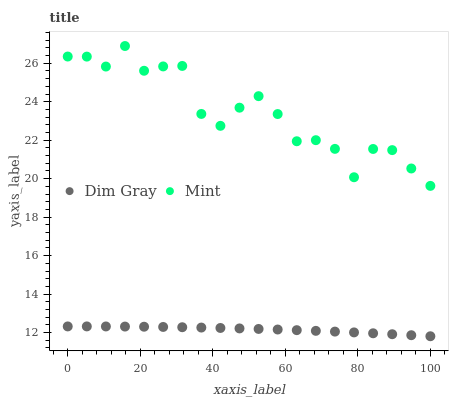Does Dim Gray have the minimum area under the curve?
Answer yes or no. Yes. Does Mint have the maximum area under the curve?
Answer yes or no. Yes. Does Mint have the minimum area under the curve?
Answer yes or no. No. Is Dim Gray the smoothest?
Answer yes or no. Yes. Is Mint the roughest?
Answer yes or no. Yes. Is Mint the smoothest?
Answer yes or no. No. Does Dim Gray have the lowest value?
Answer yes or no. Yes. Does Mint have the lowest value?
Answer yes or no. No. Does Mint have the highest value?
Answer yes or no. Yes. Is Dim Gray less than Mint?
Answer yes or no. Yes. Is Mint greater than Dim Gray?
Answer yes or no. Yes. Does Dim Gray intersect Mint?
Answer yes or no. No. 